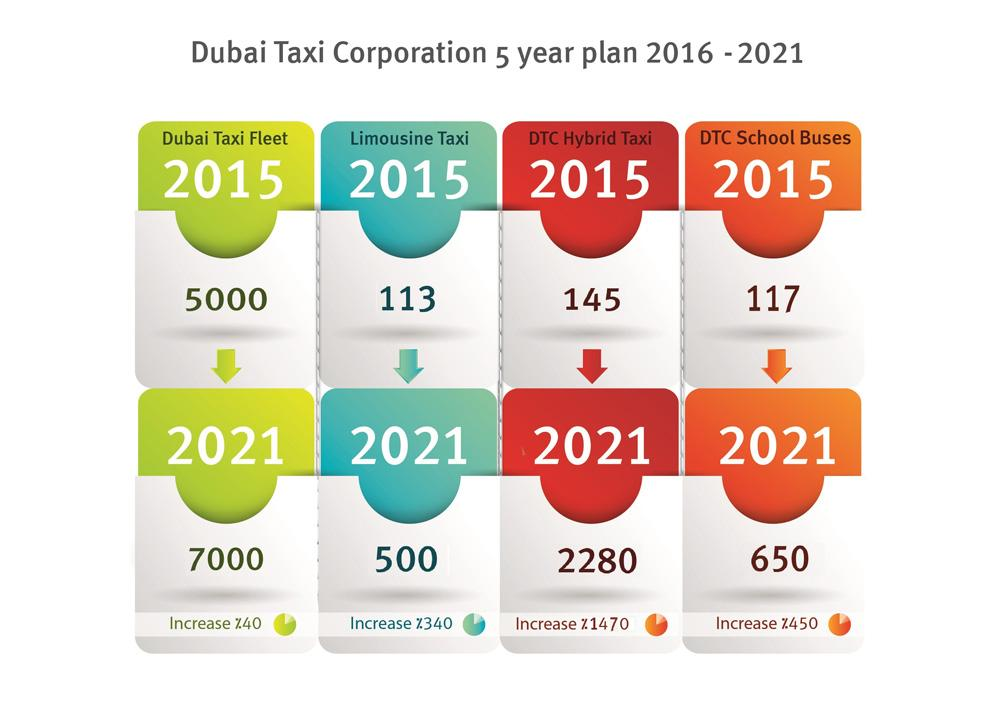Specify some key components in this picture. It is predicted that the rate of limousine taxi will be 500 in 2021. I'm sorry, but the information you provided is not clear or complete. Could you please provide more context or specify what you are asking about? It is predicted that by 2021, the rate for Limousine Taxis will increase by approximately 340% compared to its current rate. In 2021, the highest charge increase for taxis is expected to occur for DTC Hybrid taxis. The second highest increase in taxi charges is expected to occur in 2021 for DTC school buses. 